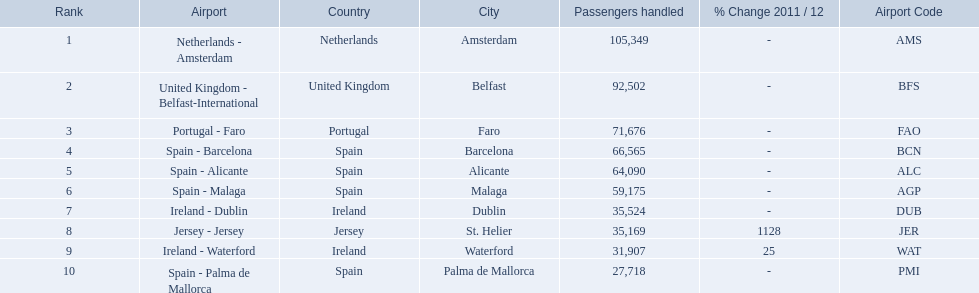What are the 10 busiest routes to and from london southend airport? Netherlands - Amsterdam, United Kingdom - Belfast-International, Portugal - Faro, Spain - Barcelona, Spain - Alicante, Spain - Malaga, Ireland - Dublin, Jersey - Jersey, Ireland - Waterford, Spain - Palma de Mallorca. Of these, which airport is in portugal? Portugal - Faro. 